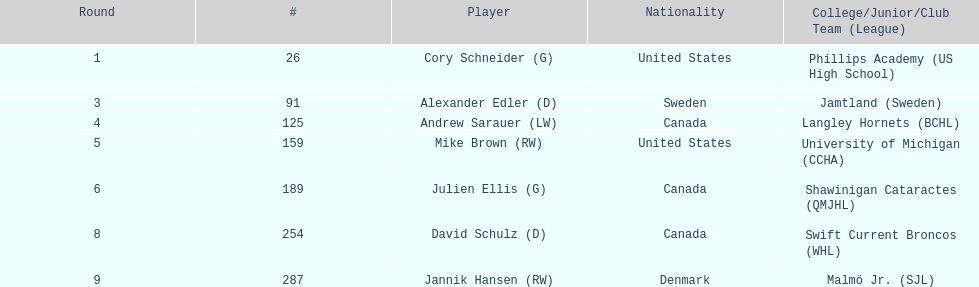The first round not to have a draft pick. 2. 